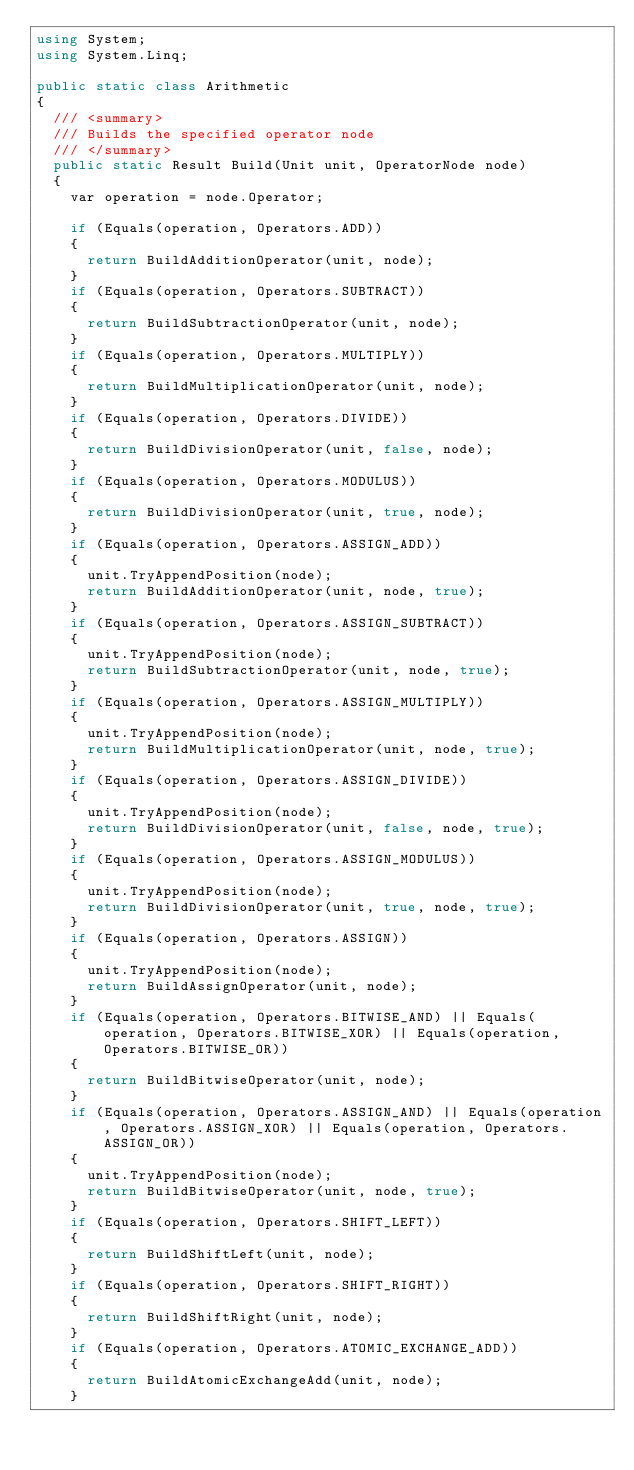<code> <loc_0><loc_0><loc_500><loc_500><_C#_>using System;
using System.Linq;

public static class Arithmetic
{
	/// <summary>
	/// Builds the specified operator node
	/// </summary>
	public static Result Build(Unit unit, OperatorNode node)
	{
		var operation = node.Operator;

		if (Equals(operation, Operators.ADD))
		{
			return BuildAdditionOperator(unit, node);
		}
		if (Equals(operation, Operators.SUBTRACT))
		{
			return BuildSubtractionOperator(unit, node);
		}
		if (Equals(operation, Operators.MULTIPLY))
		{
			return BuildMultiplicationOperator(unit, node);
		}
		if (Equals(operation, Operators.DIVIDE))
		{
			return BuildDivisionOperator(unit, false, node);
		}
		if (Equals(operation, Operators.MODULUS))
		{
			return BuildDivisionOperator(unit, true, node);
		}
		if (Equals(operation, Operators.ASSIGN_ADD))
		{
			unit.TryAppendPosition(node);
			return BuildAdditionOperator(unit, node, true);
		}
		if (Equals(operation, Operators.ASSIGN_SUBTRACT))
		{
			unit.TryAppendPosition(node);
			return BuildSubtractionOperator(unit, node, true);
		}
		if (Equals(operation, Operators.ASSIGN_MULTIPLY))
		{
			unit.TryAppendPosition(node);
			return BuildMultiplicationOperator(unit, node, true);
		}
		if (Equals(operation, Operators.ASSIGN_DIVIDE))
		{
			unit.TryAppendPosition(node);
			return BuildDivisionOperator(unit, false, node, true);
		}
		if (Equals(operation, Operators.ASSIGN_MODULUS))
		{
			unit.TryAppendPosition(node);
			return BuildDivisionOperator(unit, true, node, true);
		}
		if (Equals(operation, Operators.ASSIGN))
		{
			unit.TryAppendPosition(node);
			return BuildAssignOperator(unit, node);
		}
		if (Equals(operation, Operators.BITWISE_AND) || Equals(operation, Operators.BITWISE_XOR) || Equals(operation, Operators.BITWISE_OR))
		{
			return BuildBitwiseOperator(unit, node);
		}
		if (Equals(operation, Operators.ASSIGN_AND) || Equals(operation, Operators.ASSIGN_XOR) || Equals(operation, Operators.ASSIGN_OR))
		{
			unit.TryAppendPosition(node);
			return BuildBitwiseOperator(unit, node, true);
		}
		if (Equals(operation, Operators.SHIFT_LEFT))
		{
			return BuildShiftLeft(unit, node);
		}
		if (Equals(operation, Operators.SHIFT_RIGHT))
		{
			return BuildShiftRight(unit, node);
		}
		if (Equals(operation, Operators.ATOMIC_EXCHANGE_ADD))
		{
			return BuildAtomicExchangeAdd(unit, node);
		}</code> 